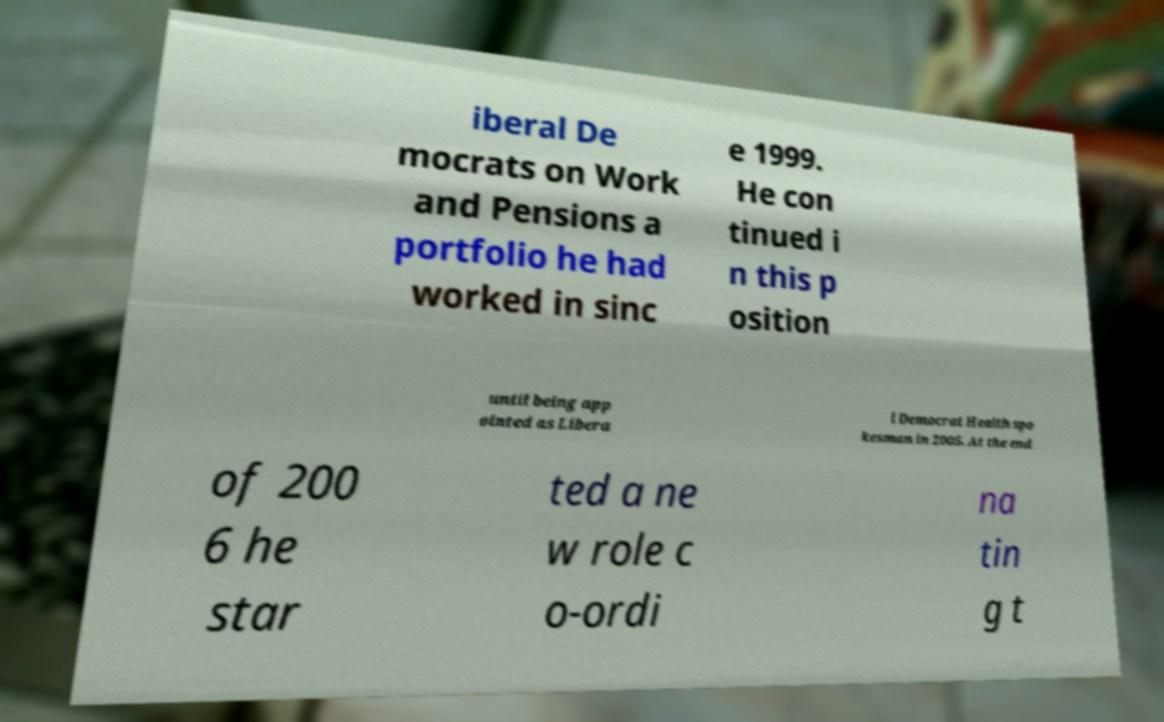For documentation purposes, I need the text within this image transcribed. Could you provide that? iberal De mocrats on Work and Pensions a portfolio he had worked in sinc e 1999. He con tinued i n this p osition until being app ointed as Libera l Democrat Health spo kesman in 2005. At the end of 200 6 he star ted a ne w role c o-ordi na tin g t 